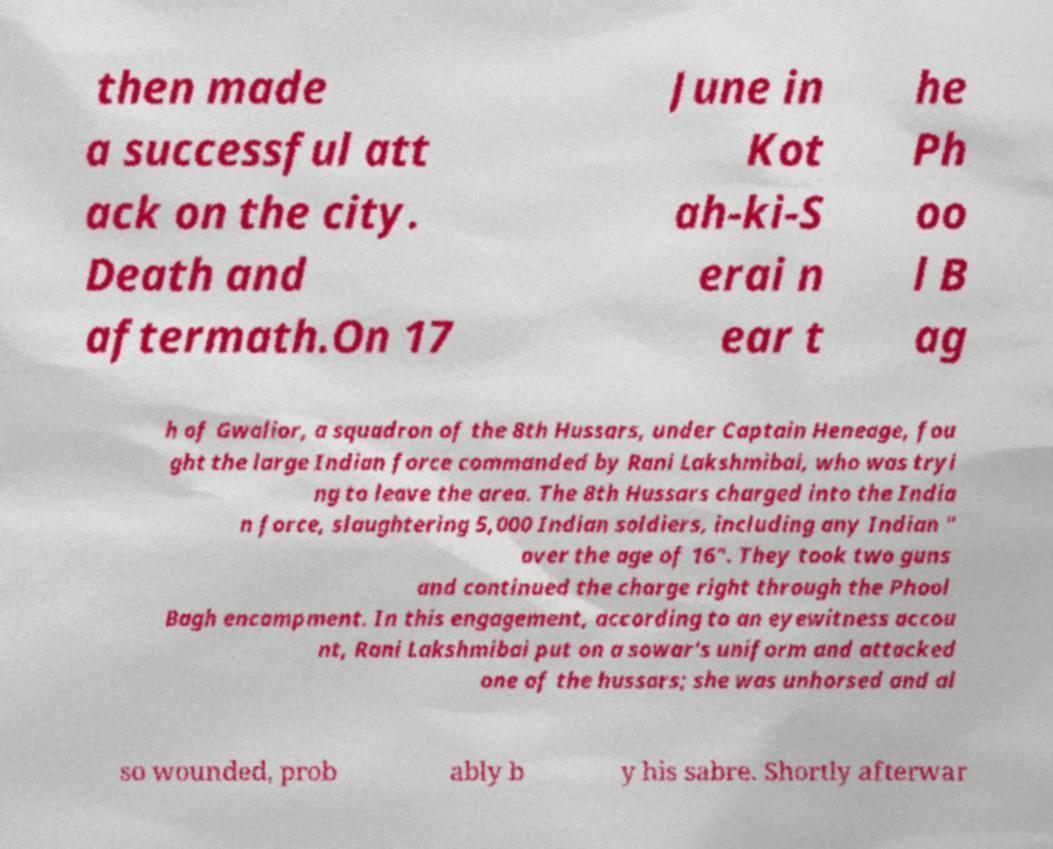Could you extract and type out the text from this image? then made a successful att ack on the city. Death and aftermath.On 17 June in Kot ah-ki-S erai n ear t he Ph oo l B ag h of Gwalior, a squadron of the 8th Hussars, under Captain Heneage, fou ght the large Indian force commanded by Rani Lakshmibai, who was tryi ng to leave the area. The 8th Hussars charged into the India n force, slaughtering 5,000 Indian soldiers, including any Indian " over the age of 16". They took two guns and continued the charge right through the Phool Bagh encampment. In this engagement, according to an eyewitness accou nt, Rani Lakshmibai put on a sowar's uniform and attacked one of the hussars; she was unhorsed and al so wounded, prob ably b y his sabre. Shortly afterwar 